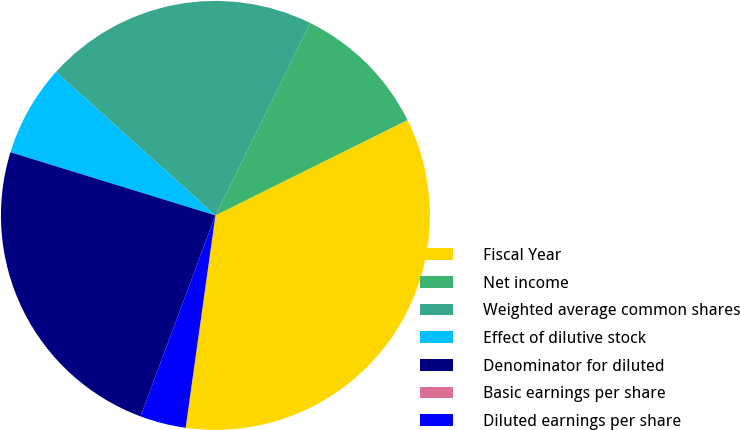<chart> <loc_0><loc_0><loc_500><loc_500><pie_chart><fcel>Fiscal Year<fcel>Net income<fcel>Weighted average common shares<fcel>Effect of dilutive stock<fcel>Denominator for diluted<fcel>Basic earnings per share<fcel>Diluted earnings per share<nl><fcel>34.55%<fcel>10.37%<fcel>20.63%<fcel>6.91%<fcel>24.08%<fcel>0.0%<fcel>3.46%<nl></chart> 